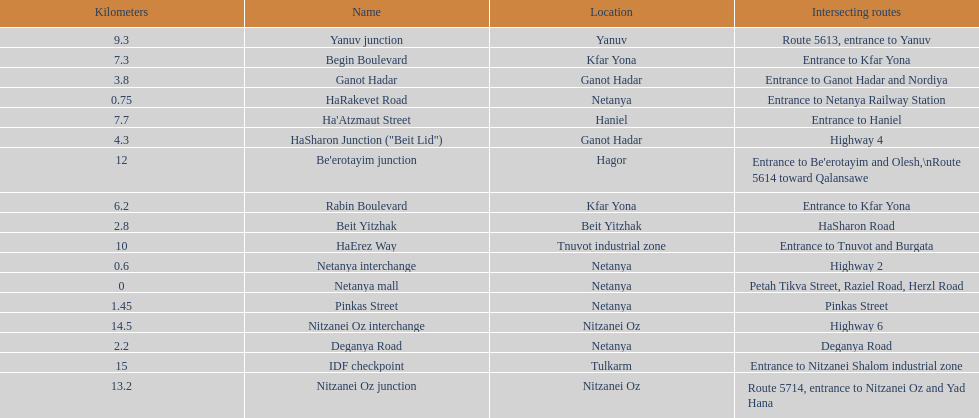Which location comes after kfar yona? Haniel. 